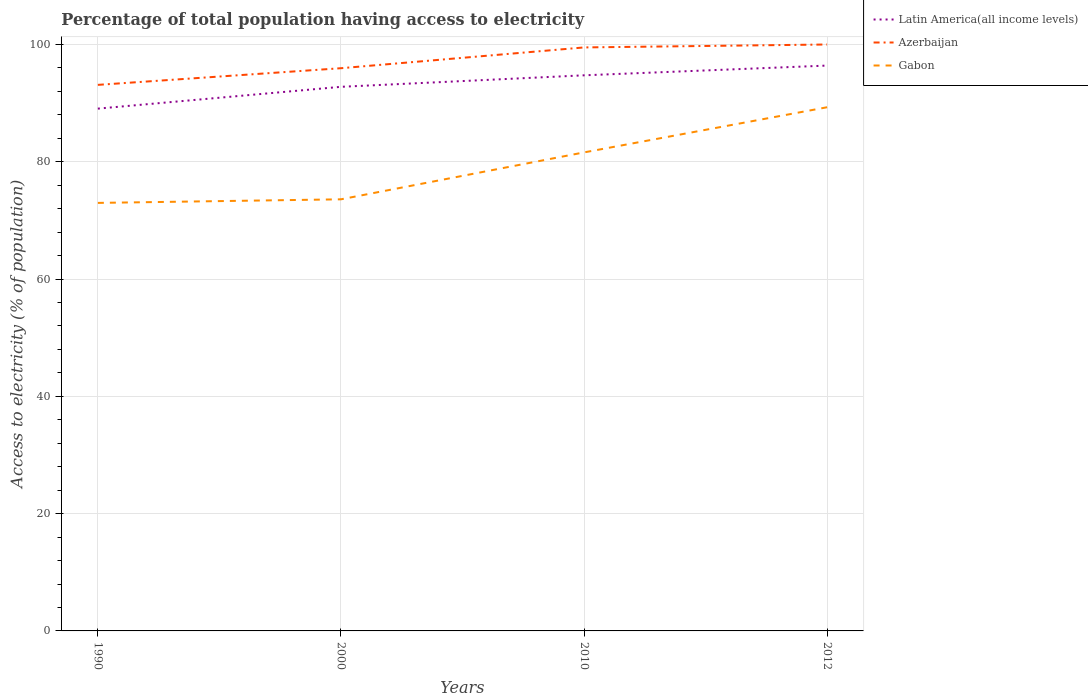Does the line corresponding to Gabon intersect with the line corresponding to Latin America(all income levels)?
Provide a short and direct response. No. Across all years, what is the maximum percentage of population that have access to electricity in Gabon?
Your answer should be compact. 72.99. In which year was the percentage of population that have access to electricity in Gabon maximum?
Your answer should be very brief. 1990. What is the total percentage of population that have access to electricity in Azerbaijan in the graph?
Give a very brief answer. -2.84. What is the difference between the highest and the second highest percentage of population that have access to electricity in Latin America(all income levels)?
Your answer should be very brief. 7.34. What is the difference between two consecutive major ticks on the Y-axis?
Offer a very short reply. 20. Are the values on the major ticks of Y-axis written in scientific E-notation?
Make the answer very short. No. Does the graph contain any zero values?
Give a very brief answer. No. Does the graph contain grids?
Offer a terse response. Yes. What is the title of the graph?
Offer a terse response. Percentage of total population having access to electricity. Does "Equatorial Guinea" appear as one of the legend labels in the graph?
Give a very brief answer. No. What is the label or title of the X-axis?
Provide a short and direct response. Years. What is the label or title of the Y-axis?
Provide a succinct answer. Access to electricity (% of population). What is the Access to electricity (% of population) of Latin America(all income levels) in 1990?
Give a very brief answer. 89.06. What is the Access to electricity (% of population) in Azerbaijan in 1990?
Your response must be concise. 93.12. What is the Access to electricity (% of population) of Gabon in 1990?
Ensure brevity in your answer.  72.99. What is the Access to electricity (% of population) of Latin America(all income levels) in 2000?
Ensure brevity in your answer.  92.78. What is the Access to electricity (% of population) of Azerbaijan in 2000?
Your answer should be compact. 95.96. What is the Access to electricity (% of population) in Gabon in 2000?
Provide a succinct answer. 73.6. What is the Access to electricity (% of population) of Latin America(all income levels) in 2010?
Keep it short and to the point. 94.75. What is the Access to electricity (% of population) of Azerbaijan in 2010?
Ensure brevity in your answer.  99.5. What is the Access to electricity (% of population) of Gabon in 2010?
Give a very brief answer. 81.6. What is the Access to electricity (% of population) in Latin America(all income levels) in 2012?
Keep it short and to the point. 96.41. What is the Access to electricity (% of population) in Azerbaijan in 2012?
Offer a terse response. 100. What is the Access to electricity (% of population) of Gabon in 2012?
Your response must be concise. 89.3. Across all years, what is the maximum Access to electricity (% of population) in Latin America(all income levels)?
Offer a terse response. 96.41. Across all years, what is the maximum Access to electricity (% of population) of Azerbaijan?
Your answer should be very brief. 100. Across all years, what is the maximum Access to electricity (% of population) of Gabon?
Provide a succinct answer. 89.3. Across all years, what is the minimum Access to electricity (% of population) of Latin America(all income levels)?
Offer a very short reply. 89.06. Across all years, what is the minimum Access to electricity (% of population) in Azerbaijan?
Keep it short and to the point. 93.12. Across all years, what is the minimum Access to electricity (% of population) in Gabon?
Your answer should be compact. 72.99. What is the total Access to electricity (% of population) of Latin America(all income levels) in the graph?
Your answer should be compact. 373. What is the total Access to electricity (% of population) in Azerbaijan in the graph?
Your answer should be very brief. 388.57. What is the total Access to electricity (% of population) of Gabon in the graph?
Provide a short and direct response. 317.49. What is the difference between the Access to electricity (% of population) of Latin America(all income levels) in 1990 and that in 2000?
Offer a terse response. -3.72. What is the difference between the Access to electricity (% of population) of Azerbaijan in 1990 and that in 2000?
Offer a terse response. -2.84. What is the difference between the Access to electricity (% of population) of Gabon in 1990 and that in 2000?
Give a very brief answer. -0.61. What is the difference between the Access to electricity (% of population) in Latin America(all income levels) in 1990 and that in 2010?
Your response must be concise. -5.68. What is the difference between the Access to electricity (% of population) in Azerbaijan in 1990 and that in 2010?
Offer a terse response. -6.38. What is the difference between the Access to electricity (% of population) of Gabon in 1990 and that in 2010?
Your response must be concise. -8.61. What is the difference between the Access to electricity (% of population) in Latin America(all income levels) in 1990 and that in 2012?
Make the answer very short. -7.34. What is the difference between the Access to electricity (% of population) in Azerbaijan in 1990 and that in 2012?
Make the answer very short. -6.88. What is the difference between the Access to electricity (% of population) of Gabon in 1990 and that in 2012?
Offer a terse response. -16.31. What is the difference between the Access to electricity (% of population) of Latin America(all income levels) in 2000 and that in 2010?
Ensure brevity in your answer.  -1.96. What is the difference between the Access to electricity (% of population) in Azerbaijan in 2000 and that in 2010?
Make the answer very short. -3.54. What is the difference between the Access to electricity (% of population) in Latin America(all income levels) in 2000 and that in 2012?
Provide a succinct answer. -3.62. What is the difference between the Access to electricity (% of population) of Azerbaijan in 2000 and that in 2012?
Your answer should be compact. -4.04. What is the difference between the Access to electricity (% of population) of Gabon in 2000 and that in 2012?
Provide a short and direct response. -15.7. What is the difference between the Access to electricity (% of population) in Latin America(all income levels) in 2010 and that in 2012?
Your answer should be compact. -1.66. What is the difference between the Access to electricity (% of population) in Azerbaijan in 2010 and that in 2012?
Offer a terse response. -0.5. What is the difference between the Access to electricity (% of population) of Latin America(all income levels) in 1990 and the Access to electricity (% of population) of Azerbaijan in 2000?
Offer a terse response. -6.89. What is the difference between the Access to electricity (% of population) of Latin America(all income levels) in 1990 and the Access to electricity (% of population) of Gabon in 2000?
Your response must be concise. 15.46. What is the difference between the Access to electricity (% of population) in Azerbaijan in 1990 and the Access to electricity (% of population) in Gabon in 2000?
Your answer should be compact. 19.52. What is the difference between the Access to electricity (% of population) of Latin America(all income levels) in 1990 and the Access to electricity (% of population) of Azerbaijan in 2010?
Make the answer very short. -10.44. What is the difference between the Access to electricity (% of population) in Latin America(all income levels) in 1990 and the Access to electricity (% of population) in Gabon in 2010?
Your answer should be compact. 7.46. What is the difference between the Access to electricity (% of population) in Azerbaijan in 1990 and the Access to electricity (% of population) in Gabon in 2010?
Provide a succinct answer. 11.52. What is the difference between the Access to electricity (% of population) of Latin America(all income levels) in 1990 and the Access to electricity (% of population) of Azerbaijan in 2012?
Offer a very short reply. -10.94. What is the difference between the Access to electricity (% of population) of Latin America(all income levels) in 1990 and the Access to electricity (% of population) of Gabon in 2012?
Offer a terse response. -0.24. What is the difference between the Access to electricity (% of population) in Azerbaijan in 1990 and the Access to electricity (% of population) in Gabon in 2012?
Provide a succinct answer. 3.82. What is the difference between the Access to electricity (% of population) of Latin America(all income levels) in 2000 and the Access to electricity (% of population) of Azerbaijan in 2010?
Offer a terse response. -6.72. What is the difference between the Access to electricity (% of population) in Latin America(all income levels) in 2000 and the Access to electricity (% of population) in Gabon in 2010?
Provide a short and direct response. 11.18. What is the difference between the Access to electricity (% of population) in Azerbaijan in 2000 and the Access to electricity (% of population) in Gabon in 2010?
Provide a short and direct response. 14.36. What is the difference between the Access to electricity (% of population) of Latin America(all income levels) in 2000 and the Access to electricity (% of population) of Azerbaijan in 2012?
Offer a terse response. -7.22. What is the difference between the Access to electricity (% of population) of Latin America(all income levels) in 2000 and the Access to electricity (% of population) of Gabon in 2012?
Give a very brief answer. 3.48. What is the difference between the Access to electricity (% of population) of Azerbaijan in 2000 and the Access to electricity (% of population) of Gabon in 2012?
Your response must be concise. 6.66. What is the difference between the Access to electricity (% of population) of Latin America(all income levels) in 2010 and the Access to electricity (% of population) of Azerbaijan in 2012?
Provide a short and direct response. -5.25. What is the difference between the Access to electricity (% of population) of Latin America(all income levels) in 2010 and the Access to electricity (% of population) of Gabon in 2012?
Your response must be concise. 5.45. What is the difference between the Access to electricity (% of population) in Azerbaijan in 2010 and the Access to electricity (% of population) in Gabon in 2012?
Your answer should be very brief. 10.2. What is the average Access to electricity (% of population) in Latin America(all income levels) per year?
Make the answer very short. 93.25. What is the average Access to electricity (% of population) in Azerbaijan per year?
Offer a terse response. 97.14. What is the average Access to electricity (% of population) of Gabon per year?
Offer a terse response. 79.37. In the year 1990, what is the difference between the Access to electricity (% of population) in Latin America(all income levels) and Access to electricity (% of population) in Azerbaijan?
Your answer should be compact. -4.05. In the year 1990, what is the difference between the Access to electricity (% of population) of Latin America(all income levels) and Access to electricity (% of population) of Gabon?
Your answer should be compact. 16.08. In the year 1990, what is the difference between the Access to electricity (% of population) in Azerbaijan and Access to electricity (% of population) in Gabon?
Your response must be concise. 20.13. In the year 2000, what is the difference between the Access to electricity (% of population) of Latin America(all income levels) and Access to electricity (% of population) of Azerbaijan?
Your response must be concise. -3.17. In the year 2000, what is the difference between the Access to electricity (% of population) of Latin America(all income levels) and Access to electricity (% of population) of Gabon?
Keep it short and to the point. 19.18. In the year 2000, what is the difference between the Access to electricity (% of population) in Azerbaijan and Access to electricity (% of population) in Gabon?
Offer a terse response. 22.36. In the year 2010, what is the difference between the Access to electricity (% of population) in Latin America(all income levels) and Access to electricity (% of population) in Azerbaijan?
Keep it short and to the point. -4.75. In the year 2010, what is the difference between the Access to electricity (% of population) of Latin America(all income levels) and Access to electricity (% of population) of Gabon?
Provide a short and direct response. 13.15. In the year 2010, what is the difference between the Access to electricity (% of population) in Azerbaijan and Access to electricity (% of population) in Gabon?
Your answer should be very brief. 17.9. In the year 2012, what is the difference between the Access to electricity (% of population) in Latin America(all income levels) and Access to electricity (% of population) in Azerbaijan?
Give a very brief answer. -3.59. In the year 2012, what is the difference between the Access to electricity (% of population) of Latin America(all income levels) and Access to electricity (% of population) of Gabon?
Offer a very short reply. 7.11. What is the ratio of the Access to electricity (% of population) in Latin America(all income levels) in 1990 to that in 2000?
Offer a very short reply. 0.96. What is the ratio of the Access to electricity (% of population) of Azerbaijan in 1990 to that in 2000?
Ensure brevity in your answer.  0.97. What is the ratio of the Access to electricity (% of population) of Azerbaijan in 1990 to that in 2010?
Give a very brief answer. 0.94. What is the ratio of the Access to electricity (% of population) in Gabon in 1990 to that in 2010?
Keep it short and to the point. 0.89. What is the ratio of the Access to electricity (% of population) in Latin America(all income levels) in 1990 to that in 2012?
Your response must be concise. 0.92. What is the ratio of the Access to electricity (% of population) in Azerbaijan in 1990 to that in 2012?
Offer a terse response. 0.93. What is the ratio of the Access to electricity (% of population) of Gabon in 1990 to that in 2012?
Your answer should be very brief. 0.82. What is the ratio of the Access to electricity (% of population) of Latin America(all income levels) in 2000 to that in 2010?
Make the answer very short. 0.98. What is the ratio of the Access to electricity (% of population) in Azerbaijan in 2000 to that in 2010?
Provide a short and direct response. 0.96. What is the ratio of the Access to electricity (% of population) in Gabon in 2000 to that in 2010?
Provide a succinct answer. 0.9. What is the ratio of the Access to electricity (% of population) in Latin America(all income levels) in 2000 to that in 2012?
Make the answer very short. 0.96. What is the ratio of the Access to electricity (% of population) in Azerbaijan in 2000 to that in 2012?
Make the answer very short. 0.96. What is the ratio of the Access to electricity (% of population) of Gabon in 2000 to that in 2012?
Offer a terse response. 0.82. What is the ratio of the Access to electricity (% of population) in Latin America(all income levels) in 2010 to that in 2012?
Offer a very short reply. 0.98. What is the ratio of the Access to electricity (% of population) of Gabon in 2010 to that in 2012?
Offer a terse response. 0.91. What is the difference between the highest and the second highest Access to electricity (% of population) in Latin America(all income levels)?
Give a very brief answer. 1.66. What is the difference between the highest and the second highest Access to electricity (% of population) of Azerbaijan?
Offer a terse response. 0.5. What is the difference between the highest and the lowest Access to electricity (% of population) of Latin America(all income levels)?
Your answer should be very brief. 7.34. What is the difference between the highest and the lowest Access to electricity (% of population) of Azerbaijan?
Ensure brevity in your answer.  6.88. What is the difference between the highest and the lowest Access to electricity (% of population) in Gabon?
Keep it short and to the point. 16.31. 